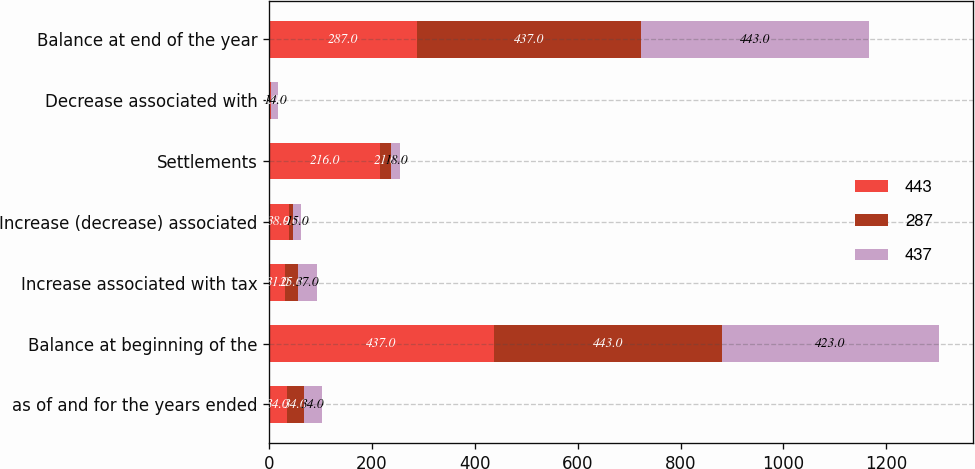Convert chart to OTSL. <chart><loc_0><loc_0><loc_500><loc_500><stacked_bar_chart><ecel><fcel>as of and for the years ended<fcel>Balance at beginning of the<fcel>Increase associated with tax<fcel>Increase (decrease) associated<fcel>Settlements<fcel>Decrease associated with<fcel>Balance at end of the year<nl><fcel>443<fcel>34<fcel>437<fcel>31<fcel>38<fcel>216<fcel>3<fcel>287<nl><fcel>287<fcel>34<fcel>443<fcel>25<fcel>9<fcel>21<fcel>1<fcel>437<nl><fcel>437<fcel>34<fcel>423<fcel>37<fcel>15<fcel>18<fcel>14<fcel>443<nl></chart> 